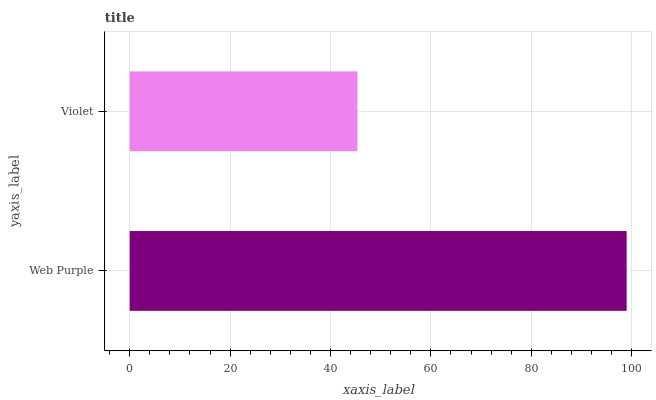Is Violet the minimum?
Answer yes or no. Yes. Is Web Purple the maximum?
Answer yes or no. Yes. Is Violet the maximum?
Answer yes or no. No. Is Web Purple greater than Violet?
Answer yes or no. Yes. Is Violet less than Web Purple?
Answer yes or no. Yes. Is Violet greater than Web Purple?
Answer yes or no. No. Is Web Purple less than Violet?
Answer yes or no. No. Is Web Purple the high median?
Answer yes or no. Yes. Is Violet the low median?
Answer yes or no. Yes. Is Violet the high median?
Answer yes or no. No. Is Web Purple the low median?
Answer yes or no. No. 